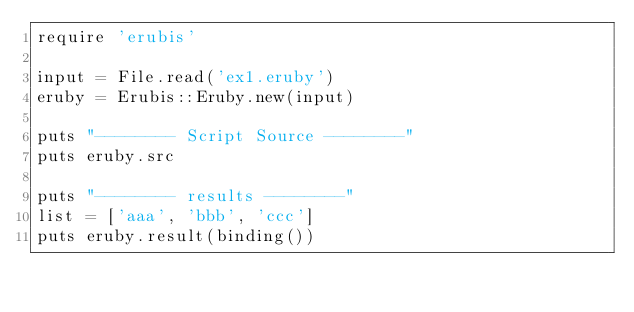<code> <loc_0><loc_0><loc_500><loc_500><_Ruby_>require 'erubis'

input = File.read('ex1.eruby')
eruby = Erubis::Eruby.new(input)

puts "-------- Script Source --------"
puts eruby.src

puts "-------- results --------"
list = ['aaa', 'bbb', 'ccc']
puts eruby.result(binding())</code> 